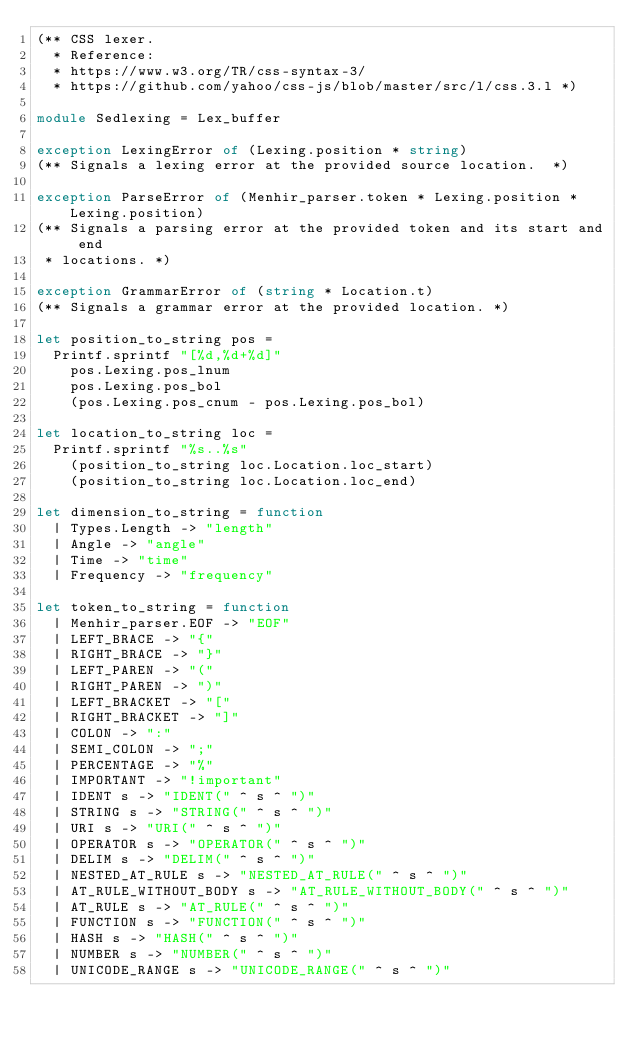<code> <loc_0><loc_0><loc_500><loc_500><_OCaml_>(** CSS lexer.
  * Reference:
  * https://www.w3.org/TR/css-syntax-3/
  * https://github.com/yahoo/css-js/blob/master/src/l/css.3.l *)

module Sedlexing = Lex_buffer

exception LexingError of (Lexing.position * string)
(** Signals a lexing error at the provided source location.  *)

exception ParseError of (Menhir_parser.token * Lexing.position * Lexing.position)
(** Signals a parsing error at the provided token and its start and end
 * locations. *)

exception GrammarError of (string * Location.t)
(** Signals a grammar error at the provided location. *)

let position_to_string pos =
  Printf.sprintf "[%d,%d+%d]"
    pos.Lexing.pos_lnum
    pos.Lexing.pos_bol
    (pos.Lexing.pos_cnum - pos.Lexing.pos_bol)

let location_to_string loc =
  Printf.sprintf "%s..%s"
    (position_to_string loc.Location.loc_start)
    (position_to_string loc.Location.loc_end)

let dimension_to_string = function
  | Types.Length -> "length"
  | Angle -> "angle"
  | Time -> "time"
  | Frequency -> "frequency"

let token_to_string = function
  | Menhir_parser.EOF -> "EOF"
  | LEFT_BRACE -> "{"
  | RIGHT_BRACE -> "}"
  | LEFT_PAREN -> "("
  | RIGHT_PAREN -> ")"
  | LEFT_BRACKET -> "["
  | RIGHT_BRACKET -> "]"
  | COLON -> ":"
  | SEMI_COLON -> ";"
  | PERCENTAGE -> "%"
  | IMPORTANT -> "!important"
  | IDENT s -> "IDENT(" ^ s ^ ")"
  | STRING s -> "STRING(" ^ s ^ ")"
  | URI s -> "URI(" ^ s ^ ")"
  | OPERATOR s -> "OPERATOR(" ^ s ^ ")"
  | DELIM s -> "DELIM(" ^ s ^ ")"
  | NESTED_AT_RULE s -> "NESTED_AT_RULE(" ^ s ^ ")"
  | AT_RULE_WITHOUT_BODY s -> "AT_RULE_WITHOUT_BODY(" ^ s ^ ")"
  | AT_RULE s -> "AT_RULE(" ^ s ^ ")"
  | FUNCTION s -> "FUNCTION(" ^ s ^ ")"
  | HASH s -> "HASH(" ^ s ^ ")"
  | NUMBER s -> "NUMBER(" ^ s ^ ")"
  | UNICODE_RANGE s -> "UNICODE_RANGE(" ^ s ^ ")"</code> 